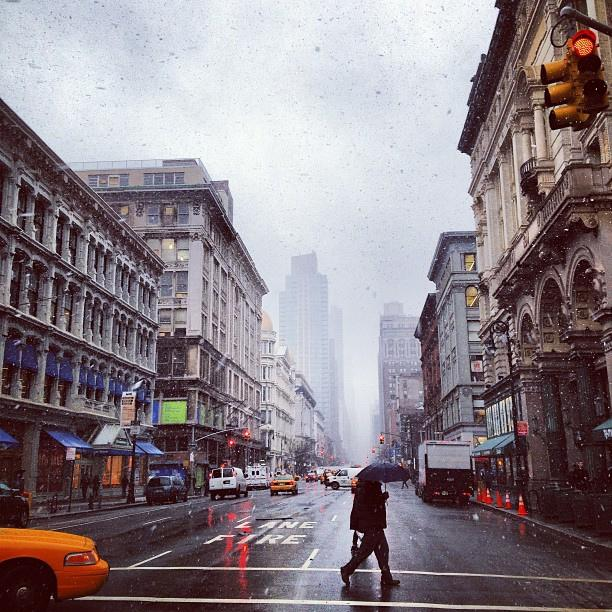What kind of vehicle can park in the middle lane? fire truck 